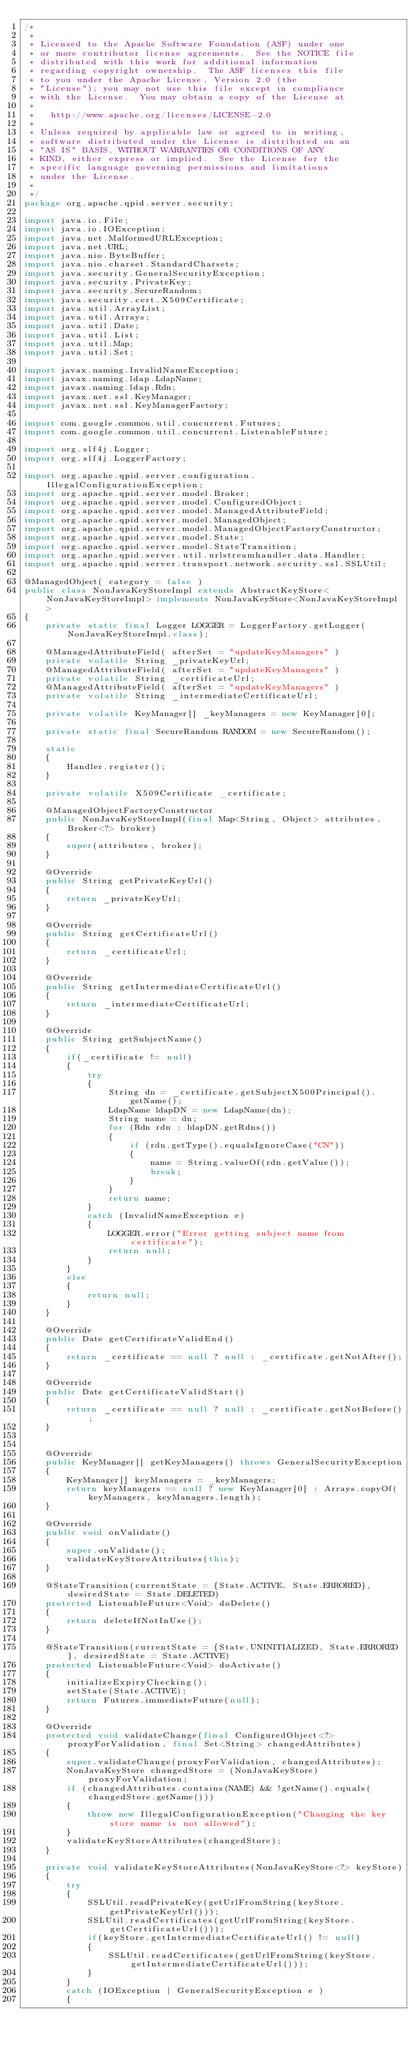Convert code to text. <code><loc_0><loc_0><loc_500><loc_500><_Java_>/*
 *
 * Licensed to the Apache Software Foundation (ASF) under one
 * or more contributor license agreements.  See the NOTICE file
 * distributed with this work for additional information
 * regarding copyright ownership.  The ASF licenses this file
 * to you under the Apache License, Version 2.0 (the
 * "License"); you may not use this file except in compliance
 * with the License.  You may obtain a copy of the License at
 *
 *   http://www.apache.org/licenses/LICENSE-2.0
 *
 * Unless required by applicable law or agreed to in writing,
 * software distributed under the License is distributed on an
 * "AS IS" BASIS, WITHOUT WARRANTIES OR CONDITIONS OF ANY
 * KIND, either express or implied.  See the License for the
 * specific language governing permissions and limitations
 * under the License.
 *
 */
package org.apache.qpid.server.security;

import java.io.File;
import java.io.IOException;
import java.net.MalformedURLException;
import java.net.URL;
import java.nio.ByteBuffer;
import java.nio.charset.StandardCharsets;
import java.security.GeneralSecurityException;
import java.security.PrivateKey;
import java.security.SecureRandom;
import java.security.cert.X509Certificate;
import java.util.ArrayList;
import java.util.Arrays;
import java.util.Date;
import java.util.List;
import java.util.Map;
import java.util.Set;

import javax.naming.InvalidNameException;
import javax.naming.ldap.LdapName;
import javax.naming.ldap.Rdn;
import javax.net.ssl.KeyManager;
import javax.net.ssl.KeyManagerFactory;

import com.google.common.util.concurrent.Futures;
import com.google.common.util.concurrent.ListenableFuture;

import org.slf4j.Logger;
import org.slf4j.LoggerFactory;

import org.apache.qpid.server.configuration.IllegalConfigurationException;
import org.apache.qpid.server.model.Broker;
import org.apache.qpid.server.model.ConfiguredObject;
import org.apache.qpid.server.model.ManagedAttributeField;
import org.apache.qpid.server.model.ManagedObject;
import org.apache.qpid.server.model.ManagedObjectFactoryConstructor;
import org.apache.qpid.server.model.State;
import org.apache.qpid.server.model.StateTransition;
import org.apache.qpid.server.util.urlstreamhandler.data.Handler;
import org.apache.qpid.server.transport.network.security.ssl.SSLUtil;

@ManagedObject( category = false )
public class NonJavaKeyStoreImpl extends AbstractKeyStore<NonJavaKeyStoreImpl> implements NonJavaKeyStore<NonJavaKeyStoreImpl>
{
    private static final Logger LOGGER = LoggerFactory.getLogger(NonJavaKeyStoreImpl.class);

    @ManagedAttributeField( afterSet = "updateKeyManagers" )
    private volatile String _privateKeyUrl;
    @ManagedAttributeField( afterSet = "updateKeyManagers" )
    private volatile String _certificateUrl;
    @ManagedAttributeField( afterSet = "updateKeyManagers" )
    private volatile String _intermediateCertificateUrl;

    private volatile KeyManager[] _keyManagers = new KeyManager[0];

    private static final SecureRandom RANDOM = new SecureRandom();

    static
    {
        Handler.register();
    }

    private volatile X509Certificate _certificate;

    @ManagedObjectFactoryConstructor
    public NonJavaKeyStoreImpl(final Map<String, Object> attributes, Broker<?> broker)
    {
        super(attributes, broker);
    }

    @Override
    public String getPrivateKeyUrl()
    {
        return _privateKeyUrl;
    }

    @Override
    public String getCertificateUrl()
    {
        return _certificateUrl;
    }

    @Override
    public String getIntermediateCertificateUrl()
    {
        return _intermediateCertificateUrl;
    }

    @Override
    public String getSubjectName()
    {
        if(_certificate != null)
        {
            try
            {
                String dn = _certificate.getSubjectX500Principal().getName();
                LdapName ldapDN = new LdapName(dn);
                String name = dn;
                for (Rdn rdn : ldapDN.getRdns())
                {
                    if (rdn.getType().equalsIgnoreCase("CN"))
                    {
                        name = String.valueOf(rdn.getValue());
                        break;
                    }
                }
                return name;
            }
            catch (InvalidNameException e)
            {
                LOGGER.error("Error getting subject name from certificate");
                return null;
            }
        }
        else
        {
            return null;
        }
    }

    @Override
    public Date getCertificateValidEnd()
    {
        return _certificate == null ? null : _certificate.getNotAfter();
    }

    @Override
    public Date getCertificateValidStart()
    {
        return _certificate == null ? null : _certificate.getNotBefore();
    }


    @Override
    public KeyManager[] getKeyManagers() throws GeneralSecurityException
    {
        KeyManager[] keyManagers = _keyManagers;
        return keyManagers == null ? new KeyManager[0] : Arrays.copyOf(keyManagers, keyManagers.length);
    }

    @Override
    public void onValidate()
    {
        super.onValidate();
        validateKeyStoreAttributes(this);
    }

    @StateTransition(currentState = {State.ACTIVE, State.ERRORED}, desiredState = State.DELETED)
    protected ListenableFuture<Void> doDelete()
    {
        return deleteIfNotInUse();
    }

    @StateTransition(currentState = {State.UNINITIALIZED, State.ERRORED}, desiredState = State.ACTIVE)
    protected ListenableFuture<Void> doActivate()
    {
        initializeExpiryChecking();
        setState(State.ACTIVE);
        return Futures.immediateFuture(null);
    }

    @Override
    protected void validateChange(final ConfiguredObject<?> proxyForValidation, final Set<String> changedAttributes)
    {
        super.validateChange(proxyForValidation, changedAttributes);
        NonJavaKeyStore changedStore = (NonJavaKeyStore) proxyForValidation;
        if (changedAttributes.contains(NAME) && !getName().equals(changedStore.getName()))
        {
            throw new IllegalConfigurationException("Changing the key store name is not allowed");
        }
        validateKeyStoreAttributes(changedStore);
    }

    private void validateKeyStoreAttributes(NonJavaKeyStore<?> keyStore)
    {
        try
        {
            SSLUtil.readPrivateKey(getUrlFromString(keyStore.getPrivateKeyUrl()));
            SSLUtil.readCertificates(getUrlFromString(keyStore.getCertificateUrl()));
            if(keyStore.getIntermediateCertificateUrl() != null)
            {
                SSLUtil.readCertificates(getUrlFromString(keyStore.getIntermediateCertificateUrl()));
            }
        }
        catch (IOException | GeneralSecurityException e )
        {</code> 